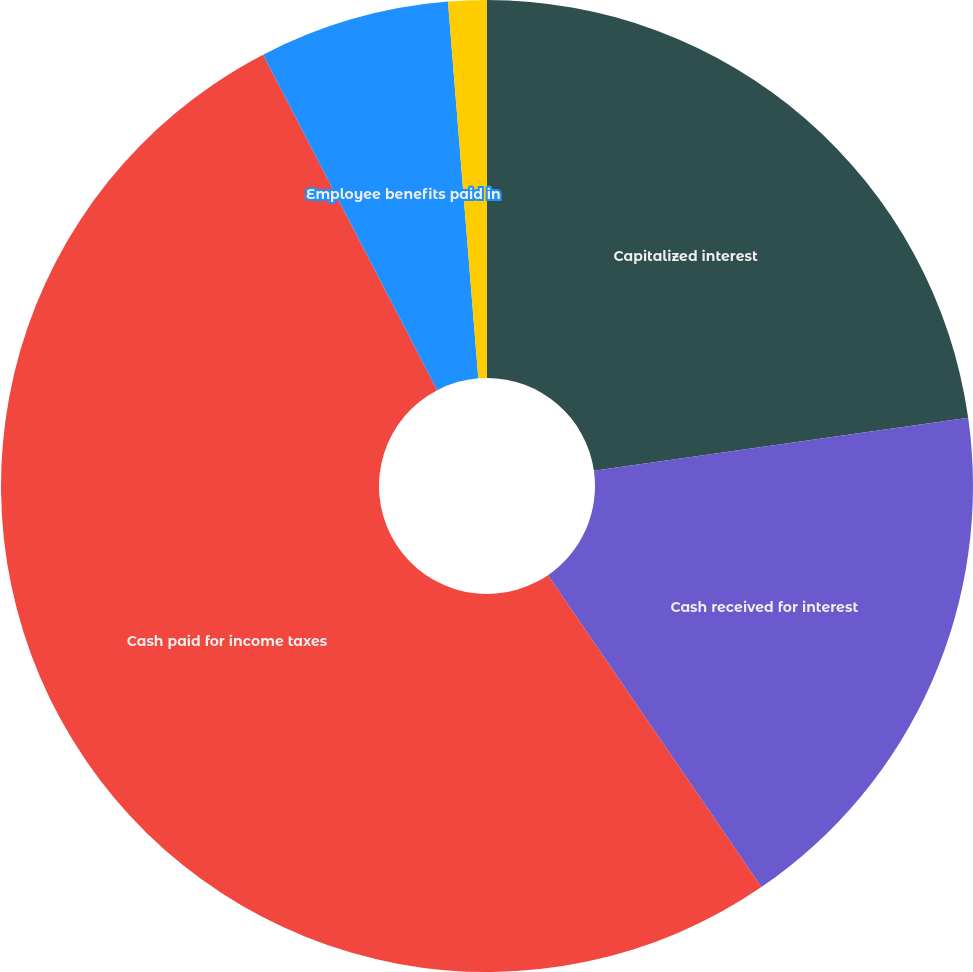Convert chart. <chart><loc_0><loc_0><loc_500><loc_500><pie_chart><fcel>Capitalized interest<fcel>Cash received for interest<fcel>Cash paid for income taxes<fcel>Employee benefits paid in<fcel>Satellites and other assets<nl><fcel>22.76%<fcel>17.69%<fcel>51.93%<fcel>6.34%<fcel>1.28%<nl></chart> 